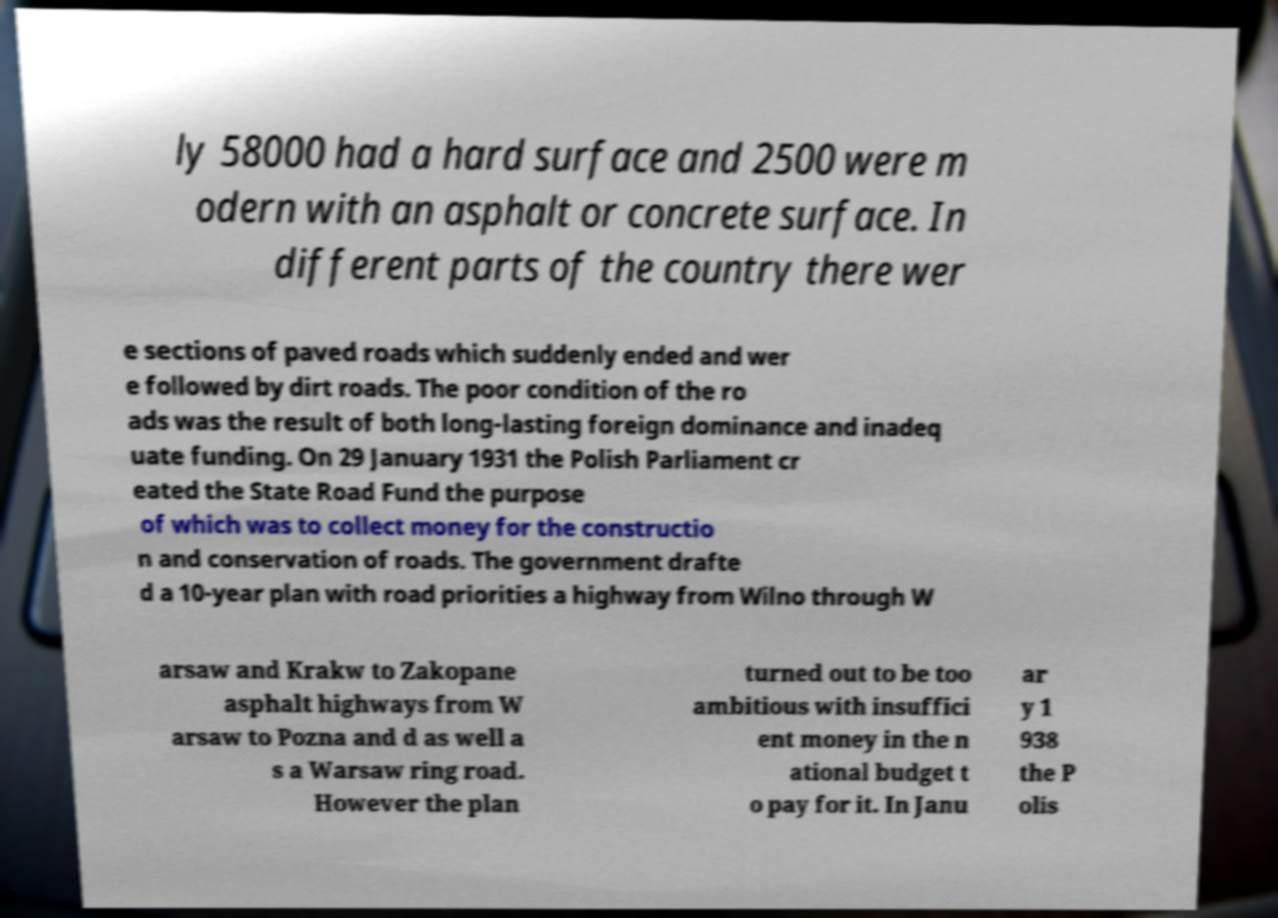Can you accurately transcribe the text from the provided image for me? ly 58000 had a hard surface and 2500 were m odern with an asphalt or concrete surface. In different parts of the country there wer e sections of paved roads which suddenly ended and wer e followed by dirt roads. The poor condition of the ro ads was the result of both long-lasting foreign dominance and inadeq uate funding. On 29 January 1931 the Polish Parliament cr eated the State Road Fund the purpose of which was to collect money for the constructio n and conservation of roads. The government drafte d a 10-year plan with road priorities a highway from Wilno through W arsaw and Krakw to Zakopane asphalt highways from W arsaw to Pozna and d as well a s a Warsaw ring road. However the plan turned out to be too ambitious with insuffici ent money in the n ational budget t o pay for it. In Janu ar y 1 938 the P olis 